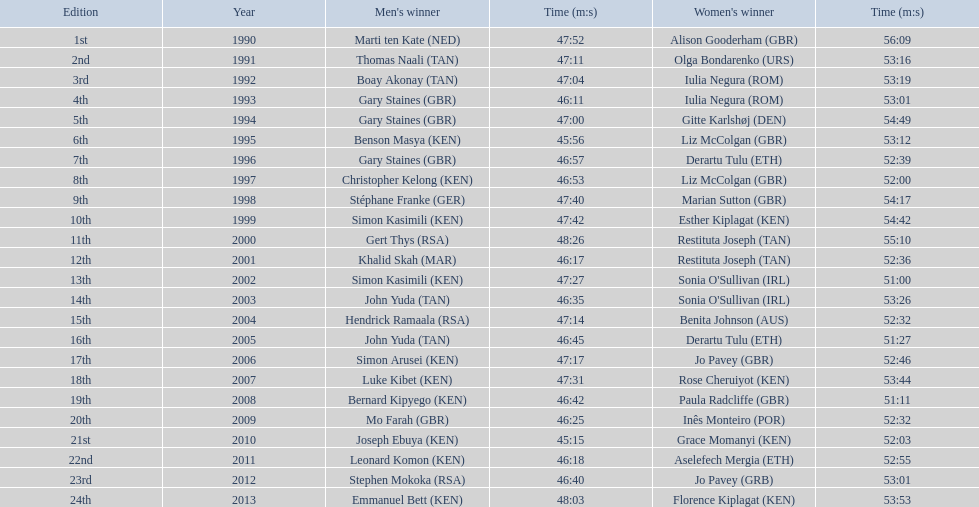What position did sonia o'sullivan end up in 2003? 14th. How much time did she need to complete? 53:26. 